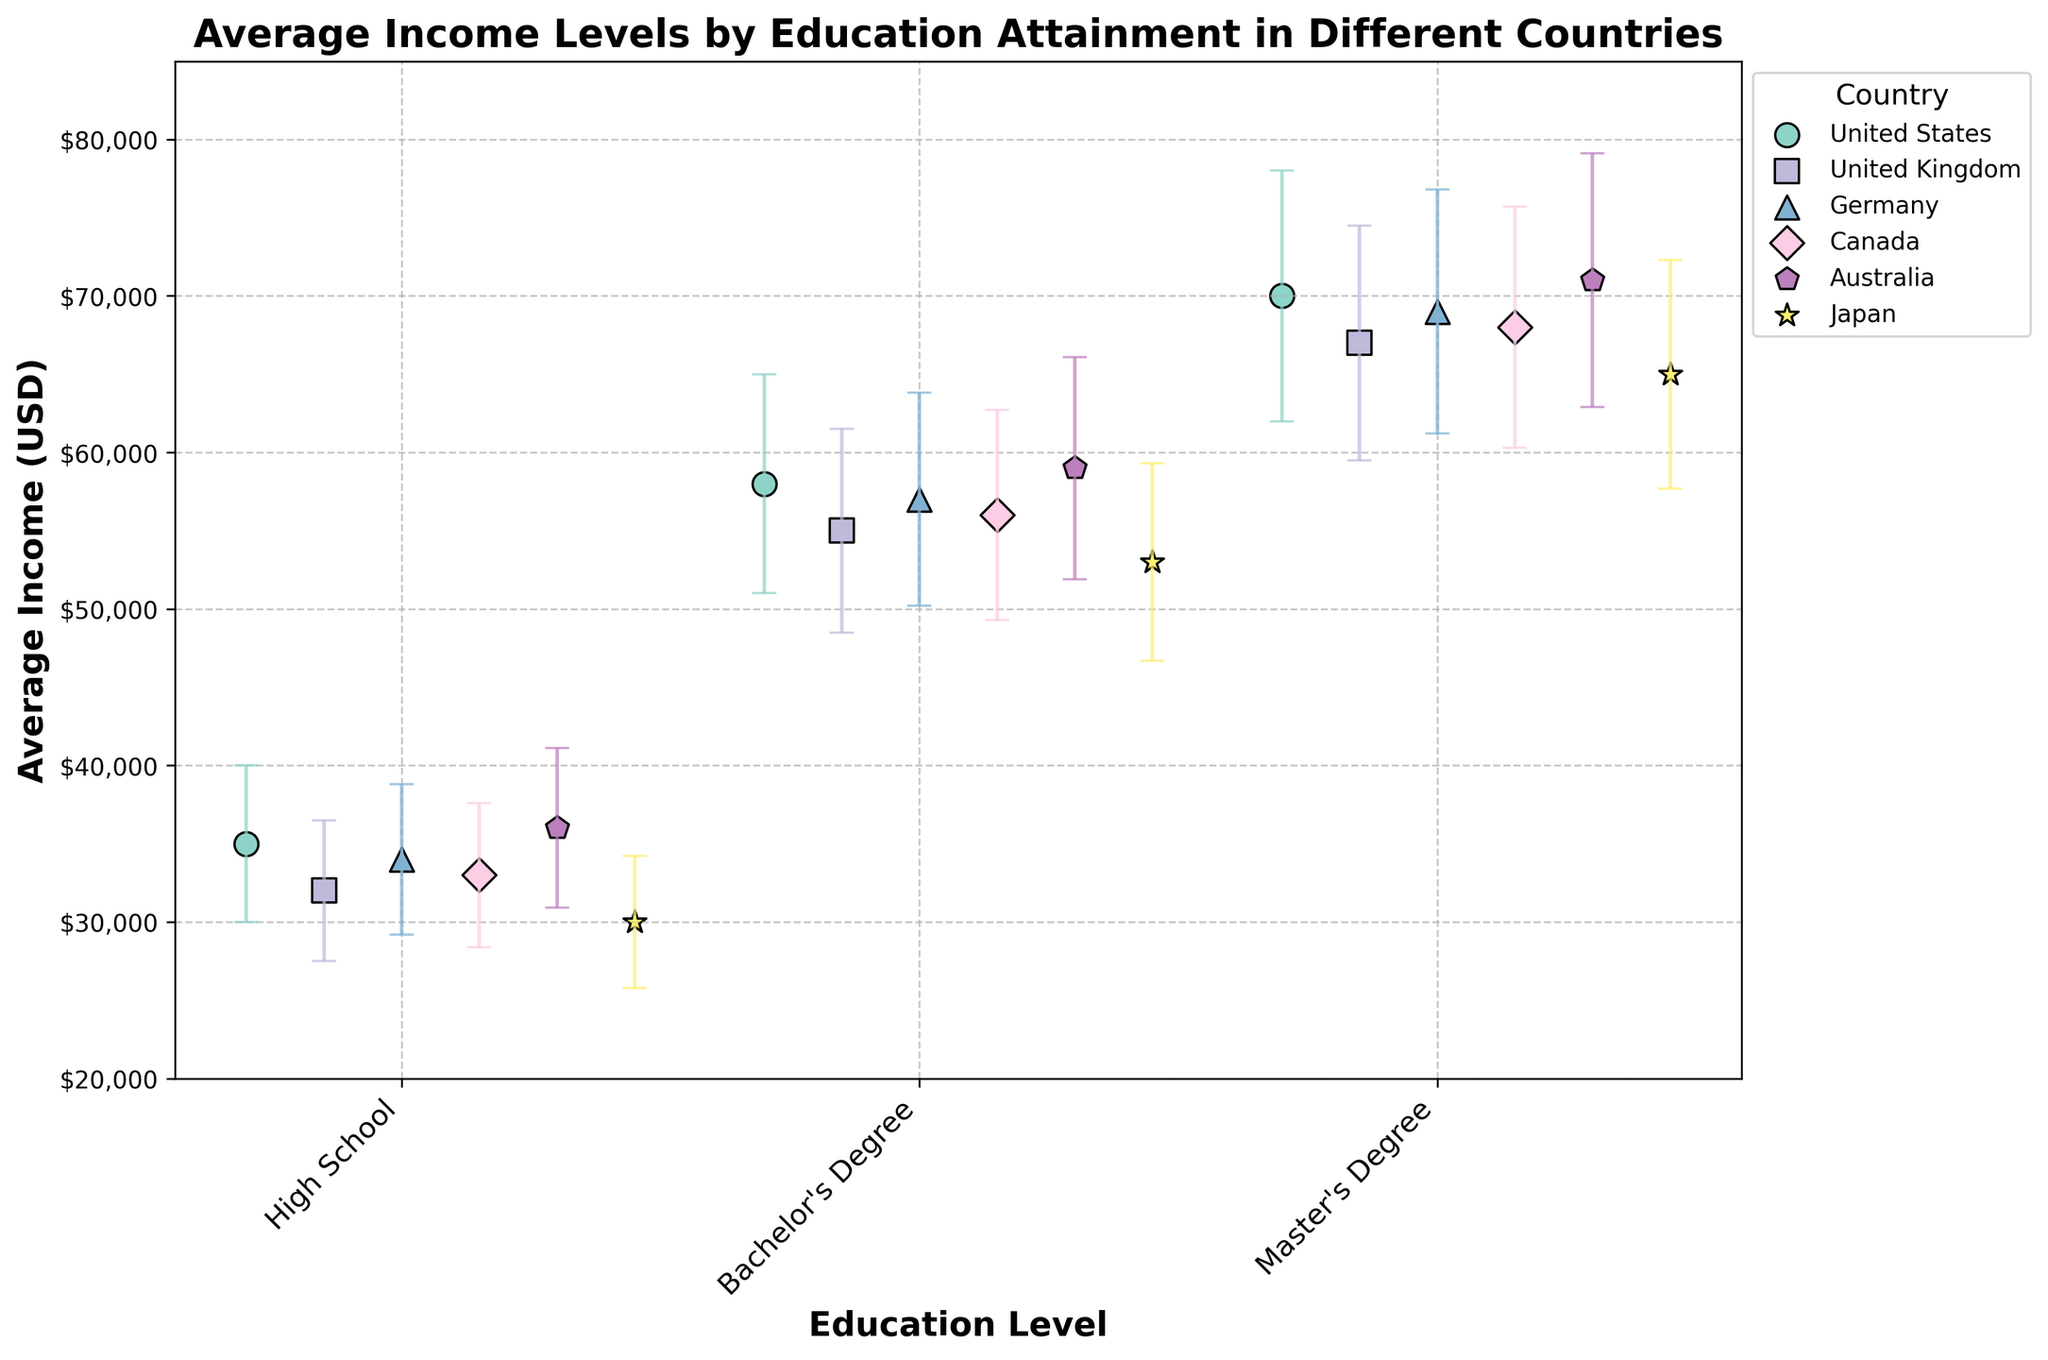What is the highest average income for a Master's Degree? The highest average income is represented by the tallest dot associated with a Master's Degree. In this case, it is in Australia, where the income is $71,000.
Answer: $71,000 What country has the lowest standard deviation for Bachelor's Degree income? By identifying the smallest error bar for the Bachelor's Degree data points, we see that Japan has the lowest standard deviation at $6,300.
Answer: Japan Which country has a higher average income for a High School education, the United States or Germany? Compare the heights of the dots for High School education. The United States has a higher average income of $35,000 compared to Germany's $34,000.
Answer: United States What is the sum of the average incomes for each education level in Canada? Add the average incomes for all educational levels in Canada: $33,000 (High School) + $56,000 (Bachelor's) + $68,000 (Master's) = $157,000.
Answer: $157,000 Which country shows the widest error bars for any education level? Look for the largest error bars across all data points. Australia has the widest error bars for Master’s Degree level at $8,100.
Answer: Australia How does the average income of a Master's Degree holder in the United States compare to a Bachelor's Degree holder in Australia? Compare the heights of the dots for these educational levels. The U.S. Master's Degree average income is $70,000, while Australia's Bachelor's Degree average income is $59,000. The U.S. has a higher average income by $11,000.
Answer: U.S. Master's Degree is higher by $11,000 Is the average income for a Master's Degree in the United Kingdom higher or lower than that in Germany? Compare the heights of the dots for the Master's Degree level. The United Kingdom's average is $67,000, while Germany's is $69,000. Therefore, the UK's average is $2,000 lower.
Answer: Lower by $2,000 What is the range of incomes for High School education across all countries? Identify the highest and lowest average incomes for High School education. The highest is Australia at $36,000, and the lowest is Japan at $30,000. The range is $36,000 - $30,000 = $6,000.
Answer: $6,000 Which education level in Canada shows the smallest variation in income? Assess the lengths of the error bars for each education level in Canada. The smallest error bar represents High School with a standard deviation of $4,600.
Answer: High School 